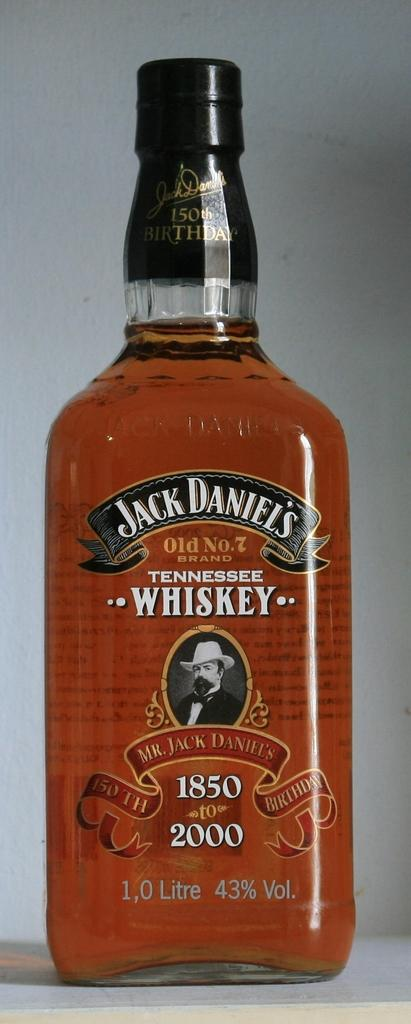<image>
Provide a brief description of the given image. A bottle of Jack Daniel's placed against white background. 